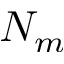Convert formula to latex. <formula><loc_0><loc_0><loc_500><loc_500>N _ { m }</formula> 